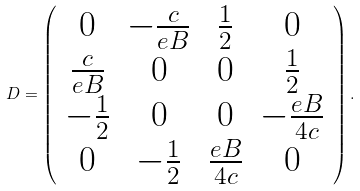<formula> <loc_0><loc_0><loc_500><loc_500>D = { \left ( \begin{array} { c c c c } 0 & - \frac { c } { e B } & \frac { 1 } { 2 } & 0 \\ \frac { c } { e B } & 0 & 0 & \frac { 1 } { 2 } \\ - \frac { 1 } { 2 } & 0 & 0 & - \frac { e B } { 4 c } \\ 0 & - \frac { 1 } { 2 } & \frac { e B } { 4 c } & 0 \end{array} \right ) } \, .</formula> 